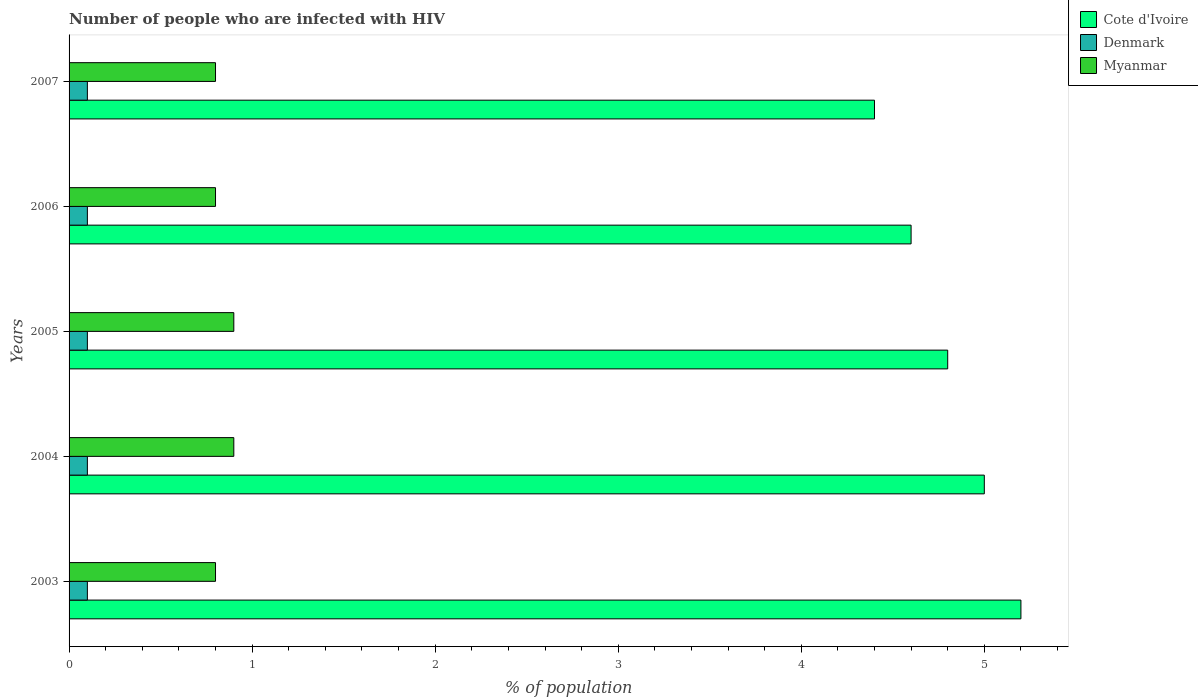How many groups of bars are there?
Your answer should be very brief. 5. Are the number of bars per tick equal to the number of legend labels?
Ensure brevity in your answer.  Yes. In how many cases, is the number of bars for a given year not equal to the number of legend labels?
Your answer should be very brief. 0. What is the percentage of HIV infected population in in Cote d'Ivoire in 2006?
Your answer should be compact. 4.6. Across all years, what is the maximum percentage of HIV infected population in in Denmark?
Provide a succinct answer. 0.1. In which year was the percentage of HIV infected population in in Myanmar maximum?
Ensure brevity in your answer.  2004. What is the total percentage of HIV infected population in in Denmark in the graph?
Make the answer very short. 0.5. What is the difference between the percentage of HIV infected population in in Cote d'Ivoire in 2003 and that in 2007?
Ensure brevity in your answer.  0.8. What is the difference between the percentage of HIV infected population in in Denmark in 2004 and the percentage of HIV infected population in in Cote d'Ivoire in 2006?
Keep it short and to the point. -4.5. What is the ratio of the percentage of HIV infected population in in Myanmar in 2003 to that in 2007?
Keep it short and to the point. 1. Is the percentage of HIV infected population in in Cote d'Ivoire in 2003 less than that in 2004?
Your answer should be very brief. No. Is the difference between the percentage of HIV infected population in in Denmark in 2003 and 2007 greater than the difference between the percentage of HIV infected population in in Myanmar in 2003 and 2007?
Offer a very short reply. No. What is the difference between the highest and the second highest percentage of HIV infected population in in Denmark?
Give a very brief answer. 0. In how many years, is the percentage of HIV infected population in in Cote d'Ivoire greater than the average percentage of HIV infected population in in Cote d'Ivoire taken over all years?
Ensure brevity in your answer.  2. Is the sum of the percentage of HIV infected population in in Cote d'Ivoire in 2005 and 2006 greater than the maximum percentage of HIV infected population in in Denmark across all years?
Keep it short and to the point. Yes. What does the 3rd bar from the top in 2007 represents?
Give a very brief answer. Cote d'Ivoire. Is it the case that in every year, the sum of the percentage of HIV infected population in in Denmark and percentage of HIV infected population in in Myanmar is greater than the percentage of HIV infected population in in Cote d'Ivoire?
Provide a succinct answer. No. How many years are there in the graph?
Keep it short and to the point. 5. Are the values on the major ticks of X-axis written in scientific E-notation?
Offer a terse response. No. Does the graph contain any zero values?
Your answer should be very brief. No. Does the graph contain grids?
Give a very brief answer. No. How many legend labels are there?
Your answer should be compact. 3. How are the legend labels stacked?
Give a very brief answer. Vertical. What is the title of the graph?
Provide a short and direct response. Number of people who are infected with HIV. Does "United Kingdom" appear as one of the legend labels in the graph?
Keep it short and to the point. No. What is the label or title of the X-axis?
Provide a succinct answer. % of population. What is the % of population of Myanmar in 2003?
Ensure brevity in your answer.  0.8. What is the % of population in Denmark in 2004?
Provide a short and direct response. 0.1. What is the % of population of Myanmar in 2004?
Give a very brief answer. 0.9. What is the % of population in Cote d'Ivoire in 2005?
Provide a succinct answer. 4.8. What is the % of population in Denmark in 2005?
Your response must be concise. 0.1. What is the % of population in Myanmar in 2005?
Provide a short and direct response. 0.9. What is the % of population in Cote d'Ivoire in 2006?
Your answer should be very brief. 4.6. What is the % of population of Denmark in 2006?
Provide a succinct answer. 0.1. What is the % of population in Cote d'Ivoire in 2007?
Your response must be concise. 4.4. What is the % of population of Denmark in 2007?
Ensure brevity in your answer.  0.1. Across all years, what is the maximum % of population of Cote d'Ivoire?
Your answer should be compact. 5.2. Across all years, what is the maximum % of population of Denmark?
Ensure brevity in your answer.  0.1. Across all years, what is the maximum % of population of Myanmar?
Keep it short and to the point. 0.9. Across all years, what is the minimum % of population of Cote d'Ivoire?
Your answer should be compact. 4.4. What is the total % of population of Myanmar in the graph?
Give a very brief answer. 4.2. What is the difference between the % of population of Cote d'Ivoire in 2003 and that in 2005?
Offer a terse response. 0.4. What is the difference between the % of population in Myanmar in 2003 and that in 2006?
Provide a short and direct response. 0. What is the difference between the % of population of Denmark in 2003 and that in 2007?
Give a very brief answer. 0. What is the difference between the % of population of Cote d'Ivoire in 2004 and that in 2005?
Give a very brief answer. 0.2. What is the difference between the % of population of Denmark in 2004 and that in 2005?
Make the answer very short. 0. What is the difference between the % of population in Myanmar in 2004 and that in 2005?
Offer a terse response. 0. What is the difference between the % of population in Denmark in 2004 and that in 2006?
Provide a short and direct response. 0. What is the difference between the % of population in Myanmar in 2004 and that in 2006?
Make the answer very short. 0.1. What is the difference between the % of population in Cote d'Ivoire in 2004 and that in 2007?
Ensure brevity in your answer.  0.6. What is the difference between the % of population of Myanmar in 2004 and that in 2007?
Offer a terse response. 0.1. What is the difference between the % of population of Denmark in 2005 and that in 2006?
Your answer should be very brief. 0. What is the difference between the % of population of Cote d'Ivoire in 2005 and that in 2007?
Your answer should be very brief. 0.4. What is the difference between the % of population of Denmark in 2005 and that in 2007?
Your answer should be very brief. 0. What is the difference between the % of population of Denmark in 2006 and that in 2007?
Your answer should be compact. 0. What is the difference between the % of population in Cote d'Ivoire in 2003 and the % of population in Denmark in 2004?
Your answer should be very brief. 5.1. What is the difference between the % of population of Cote d'Ivoire in 2003 and the % of population of Myanmar in 2004?
Give a very brief answer. 4.3. What is the difference between the % of population in Cote d'Ivoire in 2003 and the % of population in Denmark in 2005?
Your answer should be compact. 5.1. What is the difference between the % of population of Cote d'Ivoire in 2003 and the % of population of Myanmar in 2006?
Your answer should be compact. 4.4. What is the difference between the % of population in Denmark in 2003 and the % of population in Myanmar in 2006?
Your answer should be compact. -0.7. What is the difference between the % of population in Cote d'Ivoire in 2003 and the % of population in Myanmar in 2007?
Make the answer very short. 4.4. What is the difference between the % of population in Cote d'Ivoire in 2004 and the % of population in Myanmar in 2005?
Offer a very short reply. 4.1. What is the difference between the % of population in Denmark in 2004 and the % of population in Myanmar in 2005?
Your answer should be very brief. -0.8. What is the difference between the % of population of Cote d'Ivoire in 2004 and the % of population of Denmark in 2006?
Make the answer very short. 4.9. What is the difference between the % of population in Denmark in 2004 and the % of population in Myanmar in 2006?
Provide a short and direct response. -0.7. What is the difference between the % of population in Denmark in 2004 and the % of population in Myanmar in 2007?
Provide a short and direct response. -0.7. What is the difference between the % of population of Cote d'Ivoire in 2005 and the % of population of Denmark in 2006?
Offer a very short reply. 4.7. What is the difference between the % of population of Denmark in 2005 and the % of population of Myanmar in 2006?
Your answer should be very brief. -0.7. What is the difference between the % of population of Cote d'Ivoire in 2005 and the % of population of Denmark in 2007?
Give a very brief answer. 4.7. What is the difference between the % of population in Cote d'Ivoire in 2006 and the % of population in Myanmar in 2007?
Make the answer very short. 3.8. What is the difference between the % of population of Denmark in 2006 and the % of population of Myanmar in 2007?
Make the answer very short. -0.7. What is the average % of population in Cote d'Ivoire per year?
Keep it short and to the point. 4.8. What is the average % of population of Myanmar per year?
Give a very brief answer. 0.84. In the year 2003, what is the difference between the % of population in Cote d'Ivoire and % of population in Myanmar?
Ensure brevity in your answer.  4.4. In the year 2003, what is the difference between the % of population of Denmark and % of population of Myanmar?
Offer a terse response. -0.7. In the year 2004, what is the difference between the % of population in Cote d'Ivoire and % of population in Denmark?
Offer a very short reply. 4.9. In the year 2004, what is the difference between the % of population of Cote d'Ivoire and % of population of Myanmar?
Your response must be concise. 4.1. In the year 2004, what is the difference between the % of population in Denmark and % of population in Myanmar?
Ensure brevity in your answer.  -0.8. In the year 2005, what is the difference between the % of population in Cote d'Ivoire and % of population in Denmark?
Make the answer very short. 4.7. In the year 2005, what is the difference between the % of population of Cote d'Ivoire and % of population of Myanmar?
Make the answer very short. 3.9. In the year 2005, what is the difference between the % of population in Denmark and % of population in Myanmar?
Your answer should be compact. -0.8. In the year 2006, what is the difference between the % of population of Cote d'Ivoire and % of population of Denmark?
Keep it short and to the point. 4.5. In the year 2006, what is the difference between the % of population of Denmark and % of population of Myanmar?
Your answer should be very brief. -0.7. What is the ratio of the % of population in Cote d'Ivoire in 2003 to that in 2006?
Keep it short and to the point. 1.13. What is the ratio of the % of population of Denmark in 2003 to that in 2006?
Keep it short and to the point. 1. What is the ratio of the % of population of Cote d'Ivoire in 2003 to that in 2007?
Ensure brevity in your answer.  1.18. What is the ratio of the % of population of Cote d'Ivoire in 2004 to that in 2005?
Provide a succinct answer. 1.04. What is the ratio of the % of population of Myanmar in 2004 to that in 2005?
Offer a very short reply. 1. What is the ratio of the % of population in Cote d'Ivoire in 2004 to that in 2006?
Give a very brief answer. 1.09. What is the ratio of the % of population of Denmark in 2004 to that in 2006?
Offer a terse response. 1. What is the ratio of the % of population of Cote d'Ivoire in 2004 to that in 2007?
Offer a very short reply. 1.14. What is the ratio of the % of population of Myanmar in 2004 to that in 2007?
Keep it short and to the point. 1.12. What is the ratio of the % of population of Cote d'Ivoire in 2005 to that in 2006?
Your response must be concise. 1.04. What is the ratio of the % of population of Myanmar in 2005 to that in 2006?
Offer a very short reply. 1.12. What is the ratio of the % of population in Myanmar in 2005 to that in 2007?
Provide a succinct answer. 1.12. What is the ratio of the % of population in Cote d'Ivoire in 2006 to that in 2007?
Provide a short and direct response. 1.05. What is the ratio of the % of population in Denmark in 2006 to that in 2007?
Your answer should be compact. 1. What is the ratio of the % of population of Myanmar in 2006 to that in 2007?
Give a very brief answer. 1. What is the difference between the highest and the second highest % of population of Cote d'Ivoire?
Ensure brevity in your answer.  0.2. What is the difference between the highest and the second highest % of population of Denmark?
Offer a terse response. 0. What is the difference between the highest and the second highest % of population of Myanmar?
Make the answer very short. 0. What is the difference between the highest and the lowest % of population of Denmark?
Provide a short and direct response. 0. What is the difference between the highest and the lowest % of population in Myanmar?
Make the answer very short. 0.1. 